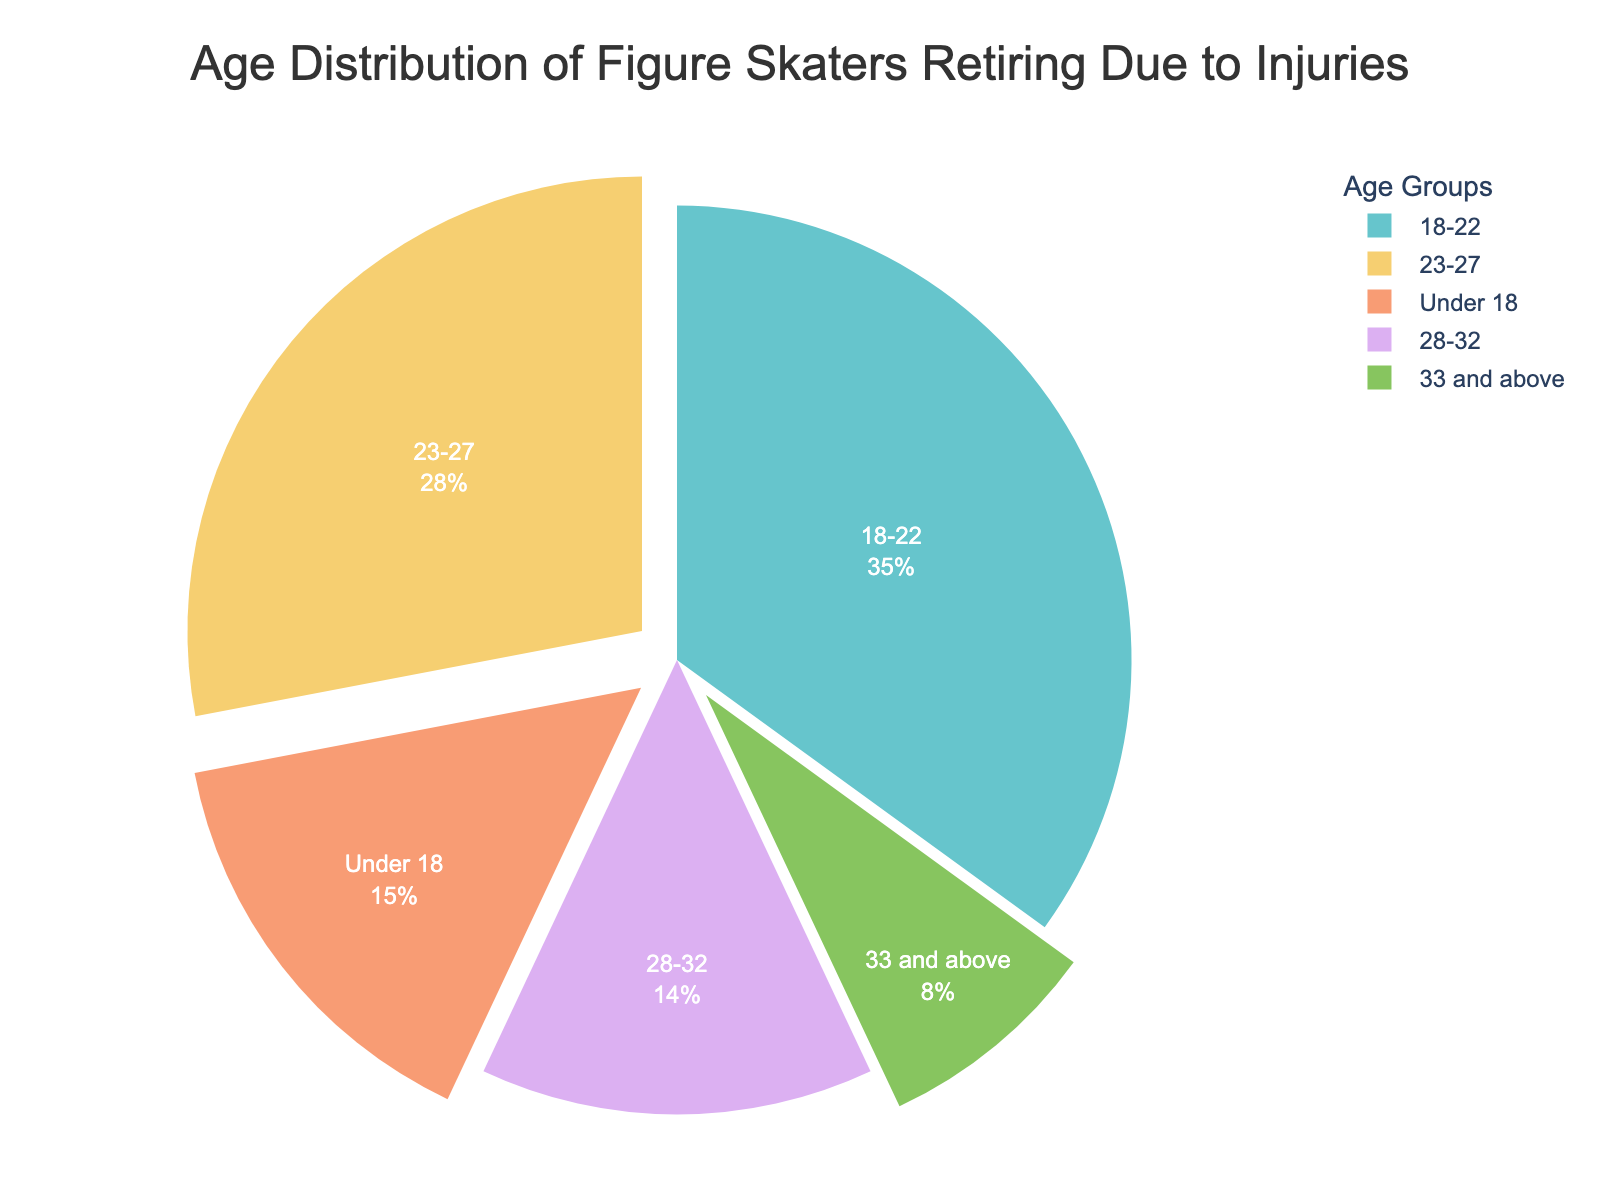What age group represents the largest percentage of figure skaters retiring due to injuries? The pie chart shows that the age group 18-22 has the largest segment. This can be determined by visually identifying the largest portion of the pie chart.
Answer: 18-22 How many percentage points greater is the "18-22" age group compared to the "Under 18" age group? The "18-22" age group is 35%, while the "Under 18" age group is 15%. Subtract 15 from 35 to find the difference.
Answer: 20 What is the combined percentage of skaters retiring between ages 23 and 32? Add the percentages of the age groups "23-27" and "28-32": 28% + 14% = 42%.
Answer: 42% Which age group has the smallest percentage of figure skaters retiring due to injuries? The pie chart shows that the age group "33 and above" has the smallest segment. This can be determined by visually identifying the smallest portion of the pie chart.
Answer: 33 and above Is the percentage of skaters retiring due to injuries higher for those under 18 or those 33 and above? Compare the percentages for the "Under 18" (15%) and "33 and above" (8%). 15% is greater than 8%.
Answer: Under 18 What is the percentage difference between the "23-27" and "28-32" age groups? The "23-27" age group is 28%, and the "28-32" age group is 14%. Subtract 14 from 28 to find the difference.
Answer: 14 Which age groups have a percentage of retiring skaters that is less than 20%? Look at the percentages on the pie chart: "Under 18" (15%), "28-32" (14%), and "33 and above" (8%) all have percentages less than 20%.
Answer: Under 18, 28-32, 33 and above What is the visual attribute used to distinguish different age groups on the pie chart? The pie chart uses different colors to distinguish between the age groups.
Answer: Colors 